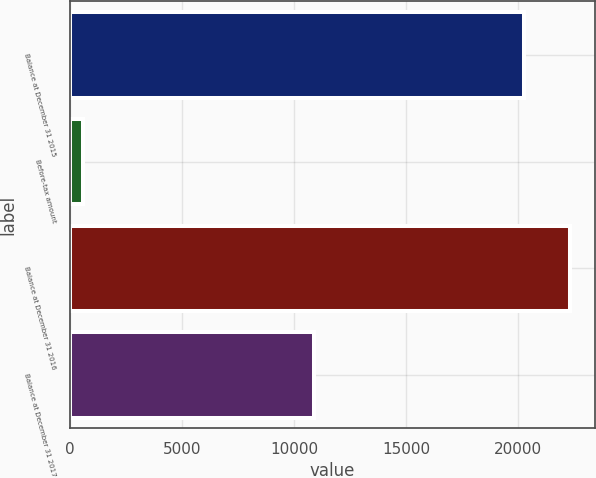<chart> <loc_0><loc_0><loc_500><loc_500><bar_chart><fcel>Balance at December 31 2015<fcel>Before-tax amount<fcel>Balance at December 31 2016<fcel>Balance at December 31 2017<nl><fcel>20273<fcel>602<fcel>22300.3<fcel>10915<nl></chart> 